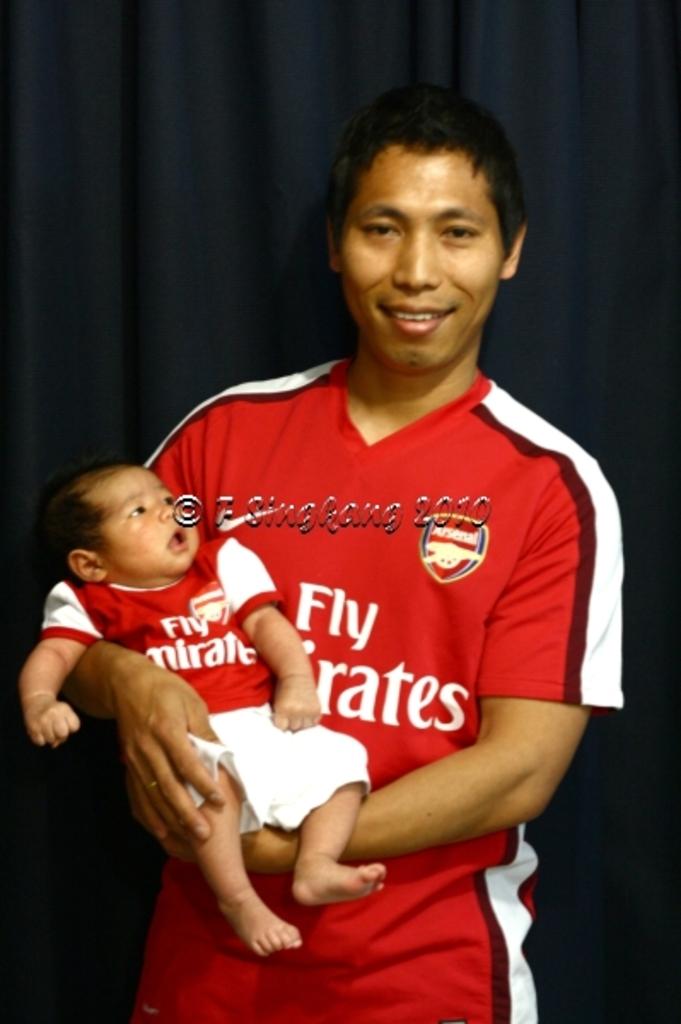What year was this photo taken?
Your answer should be very brief. 2010. 